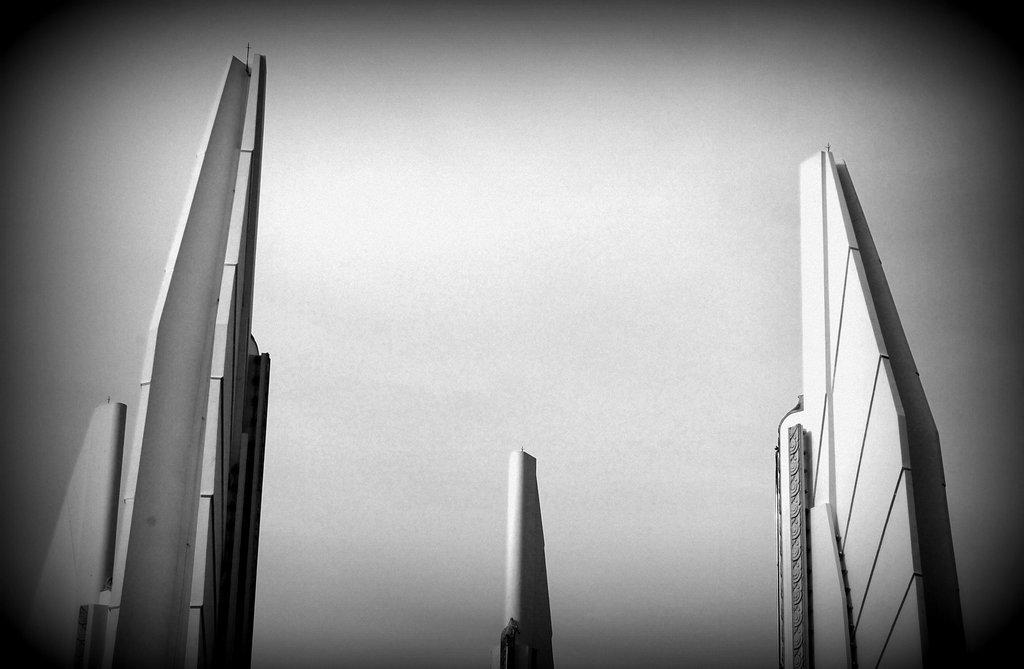What type of structures can be seen in the image? There are buildings in the image. What part of the natural environment is visible in the image? The sky is visible in the image. How is the image presented in terms of color? The image is in black and white mode. What type of trousers are being worn by the buildings in the image? Buildings do not wear trousers, as they are inanimate structures. What is the size of the toys visible in the image? There are no toys present in the image. 